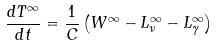<formula> <loc_0><loc_0><loc_500><loc_500>\frac { d T ^ { \infty } } { d t } = \frac { 1 } { C } \left ( W ^ { \infty } - L _ { \nu } ^ { \infty } - L _ { \gamma } ^ { \infty } \right )</formula> 